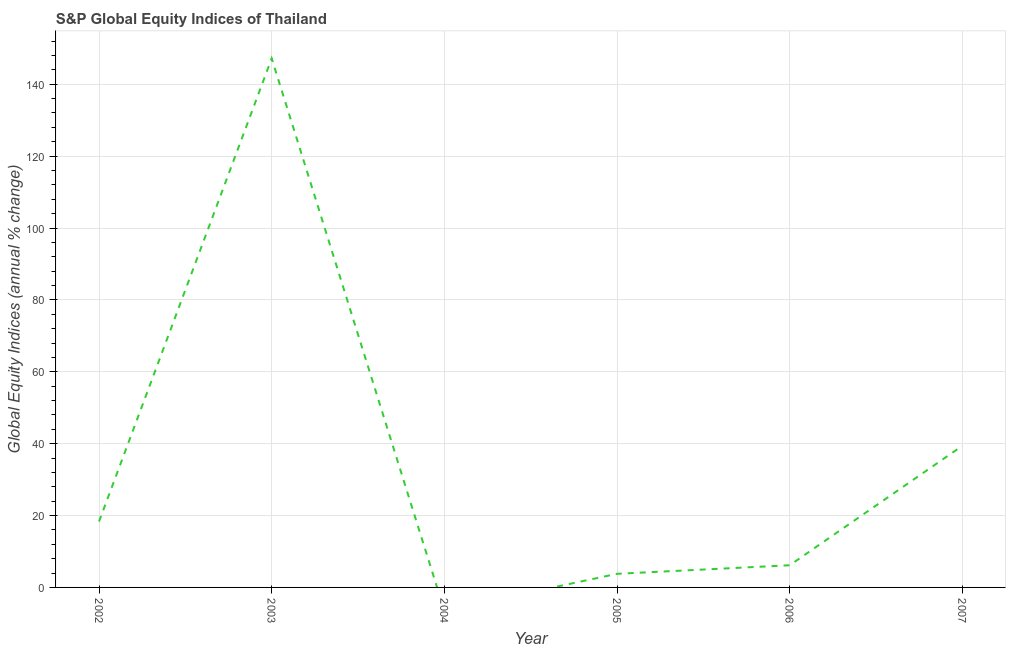Across all years, what is the maximum s&p global equity indices?
Offer a very short reply. 147.18. Across all years, what is the minimum s&p global equity indices?
Ensure brevity in your answer.  0. What is the sum of the s&p global equity indices?
Provide a short and direct response. 214.88. What is the difference between the s&p global equity indices in 2002 and 2005?
Your response must be concise. 14.55. What is the average s&p global equity indices per year?
Provide a succinct answer. 35.81. What is the median s&p global equity indices?
Your response must be concise. 12.25. In how many years, is the s&p global equity indices greater than 112 %?
Keep it short and to the point. 1. What is the ratio of the s&p global equity indices in 2003 to that in 2005?
Give a very brief answer. 38.84. What is the difference between the highest and the second highest s&p global equity indices?
Ensure brevity in your answer.  107.78. Is the sum of the s&p global equity indices in 2002 and 2003 greater than the maximum s&p global equity indices across all years?
Provide a short and direct response. Yes. What is the difference between the highest and the lowest s&p global equity indices?
Provide a short and direct response. 147.18. Are the values on the major ticks of Y-axis written in scientific E-notation?
Give a very brief answer. No. Does the graph contain any zero values?
Keep it short and to the point. Yes. What is the title of the graph?
Your response must be concise. S&P Global Equity Indices of Thailand. What is the label or title of the X-axis?
Provide a succinct answer. Year. What is the label or title of the Y-axis?
Make the answer very short. Global Equity Indices (annual % change). What is the Global Equity Indices (annual % change) in 2002?
Ensure brevity in your answer.  18.34. What is the Global Equity Indices (annual % change) of 2003?
Provide a short and direct response. 147.18. What is the Global Equity Indices (annual % change) of 2004?
Provide a succinct answer. 0. What is the Global Equity Indices (annual % change) of 2005?
Provide a short and direct response. 3.79. What is the Global Equity Indices (annual % change) in 2006?
Offer a terse response. 6.17. What is the Global Equity Indices (annual % change) of 2007?
Give a very brief answer. 39.4. What is the difference between the Global Equity Indices (annual % change) in 2002 and 2003?
Keep it short and to the point. -128.84. What is the difference between the Global Equity Indices (annual % change) in 2002 and 2005?
Keep it short and to the point. 14.55. What is the difference between the Global Equity Indices (annual % change) in 2002 and 2006?
Your answer should be very brief. 12.17. What is the difference between the Global Equity Indices (annual % change) in 2002 and 2007?
Ensure brevity in your answer.  -21.06. What is the difference between the Global Equity Indices (annual % change) in 2003 and 2005?
Your answer should be very brief. 143.39. What is the difference between the Global Equity Indices (annual % change) in 2003 and 2006?
Make the answer very short. 141.01. What is the difference between the Global Equity Indices (annual % change) in 2003 and 2007?
Keep it short and to the point. 107.78. What is the difference between the Global Equity Indices (annual % change) in 2005 and 2006?
Your answer should be very brief. -2.38. What is the difference between the Global Equity Indices (annual % change) in 2005 and 2007?
Offer a very short reply. -35.61. What is the difference between the Global Equity Indices (annual % change) in 2006 and 2007?
Ensure brevity in your answer.  -33.23. What is the ratio of the Global Equity Indices (annual % change) in 2002 to that in 2003?
Keep it short and to the point. 0.12. What is the ratio of the Global Equity Indices (annual % change) in 2002 to that in 2005?
Provide a succinct answer. 4.84. What is the ratio of the Global Equity Indices (annual % change) in 2002 to that in 2006?
Your answer should be compact. 2.97. What is the ratio of the Global Equity Indices (annual % change) in 2002 to that in 2007?
Offer a very short reply. 0.47. What is the ratio of the Global Equity Indices (annual % change) in 2003 to that in 2005?
Your response must be concise. 38.84. What is the ratio of the Global Equity Indices (annual % change) in 2003 to that in 2006?
Your answer should be compact. 23.86. What is the ratio of the Global Equity Indices (annual % change) in 2003 to that in 2007?
Provide a succinct answer. 3.74. What is the ratio of the Global Equity Indices (annual % change) in 2005 to that in 2006?
Provide a short and direct response. 0.61. What is the ratio of the Global Equity Indices (annual % change) in 2005 to that in 2007?
Keep it short and to the point. 0.1. What is the ratio of the Global Equity Indices (annual % change) in 2006 to that in 2007?
Provide a succinct answer. 0.16. 